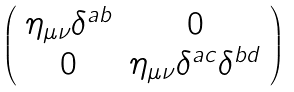Convert formula to latex. <formula><loc_0><loc_0><loc_500><loc_500>\left ( \begin{array} { c c } \eta _ { \mu \nu } \delta ^ { a b } & 0 \\ 0 & \eta _ { \mu \nu } \delta ^ { a c } \delta ^ { b d } \\ \end{array} \right )</formula> 